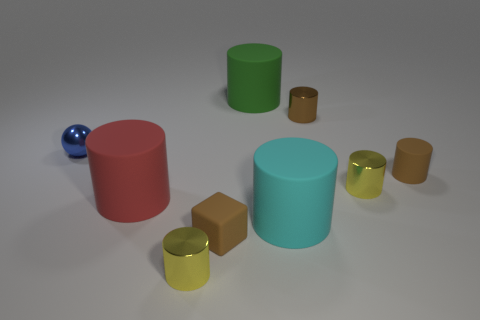Subtract 4 cylinders. How many cylinders are left? 3 Subtract all green cylinders. How many cylinders are left? 6 Subtract all red cylinders. How many cylinders are left? 6 Subtract all red cylinders. Subtract all blue blocks. How many cylinders are left? 6 Subtract all spheres. How many objects are left? 8 Add 2 metal spheres. How many metal spheres are left? 3 Add 7 blue spheres. How many blue spheres exist? 8 Subtract 0 purple cylinders. How many objects are left? 9 Subtract all tiny objects. Subtract all brown things. How many objects are left? 0 